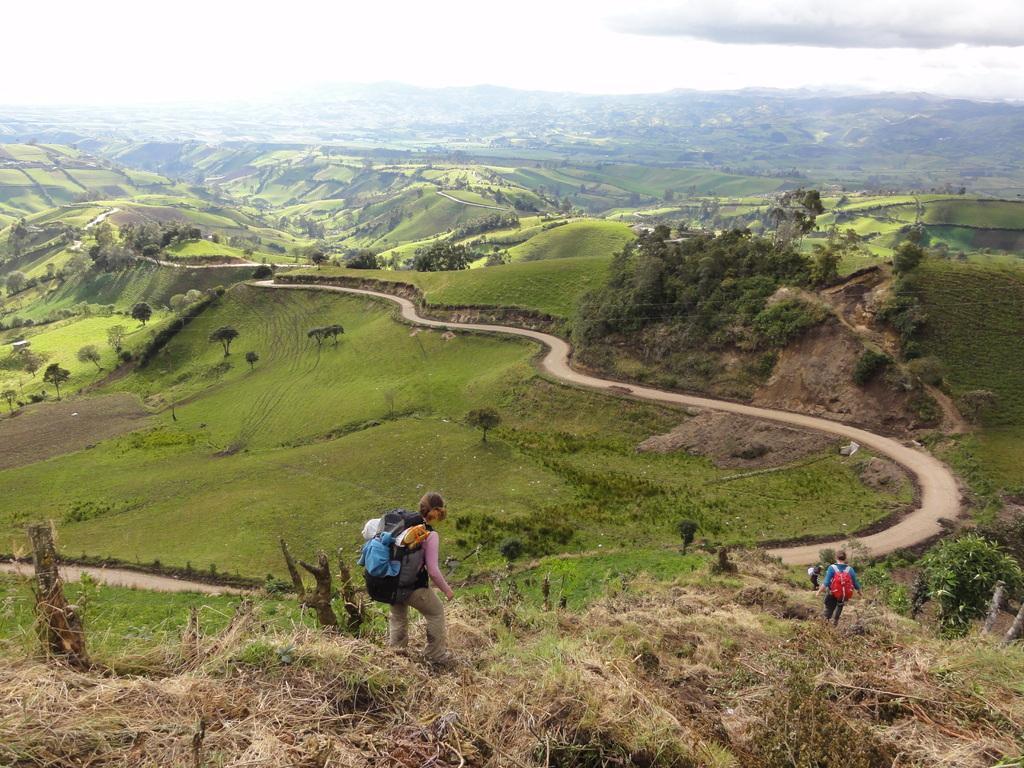Please provide a concise description of this image. In this picture I can observe some people walking. In the background there are trees. I can observe some clouds in the sky. 